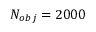<formula> <loc_0><loc_0><loc_500><loc_500>N _ { o b j } = 2 0 0 0</formula> 